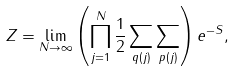<formula> <loc_0><loc_0><loc_500><loc_500>Z = \lim _ { N \rightarrow \infty } \left ( \prod _ { j = 1 } ^ { N } \frac { 1 } { 2 } \sum _ { q ( j ) } \sum _ { p ( j ) } \right ) e ^ { - S } ,</formula> 